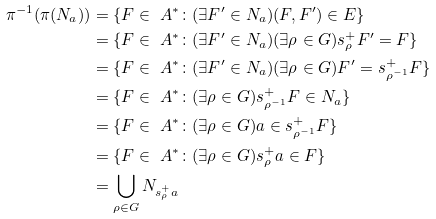Convert formula to latex. <formula><loc_0><loc_0><loc_500><loc_500>\pi ^ { - 1 } ( \pi ( N _ { a } ) ) & = \{ F \in \ A ^ { * } \colon ( \exists F ^ { \prime } \in N _ { a } ) ( F , F ^ { \prime } ) \in E \} \\ & = \{ F \in \ A ^ { * } \colon ( \exists F ^ { \prime } \in N _ { a } ) ( \exists \rho \in G ) s ^ { + } _ { \rho } F ^ { \prime } = F \} \\ & = \{ F \in \ A ^ { * } \colon ( \exists F ^ { \prime } \in N _ { a } ) ( \exists \rho \in G ) F ^ { \prime } = s ^ { + } _ { \rho ^ { - 1 } } F \} \\ & = \{ F \in \ A ^ { * } \colon ( \exists \rho \in G ) s ^ { + } _ { \rho ^ { - 1 } } F \in N _ { a } \} \\ & = \{ F \in \ A ^ { * } \colon ( \exists \rho \in G ) a \in s ^ { + } _ { \rho ^ { - 1 } } F \} \\ & = \{ F \in \ A ^ { * } \colon ( \exists \rho \in G ) s ^ { + } _ { \rho } a \in F \} \\ & = \bigcup _ { \rho \in G } N _ { s ^ { + } _ { \rho } a }</formula> 